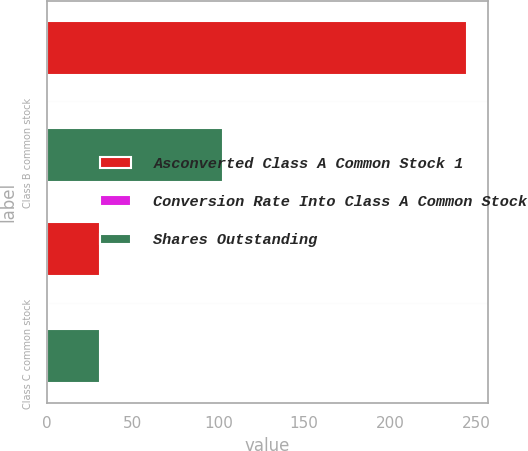Convert chart. <chart><loc_0><loc_0><loc_500><loc_500><stacked_bar_chart><ecel><fcel>Class B common stock<fcel>Class C common stock<nl><fcel>Asconverted Class A Common Stock 1<fcel>245<fcel>31<nl><fcel>Conversion Rate Into Class A Common Stock<fcel>0.42<fcel>1<nl><fcel>Shares Outstanding<fcel>103<fcel>31<nl></chart> 